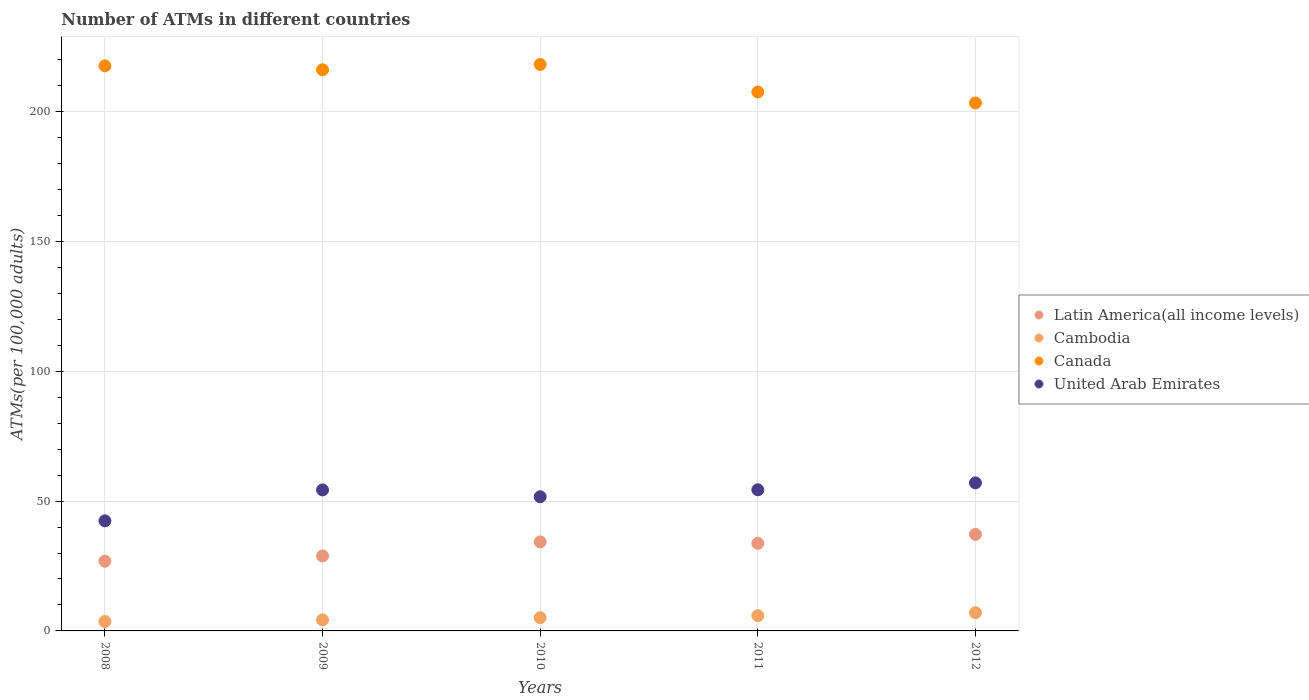How many different coloured dotlines are there?
Give a very brief answer. 4. What is the number of ATMs in United Arab Emirates in 2012?
Offer a very short reply. 57.01. Across all years, what is the maximum number of ATMs in Canada?
Make the answer very short. 218.18. Across all years, what is the minimum number of ATMs in Cambodia?
Your answer should be very brief. 3.63. In which year was the number of ATMs in Cambodia maximum?
Make the answer very short. 2012. In which year was the number of ATMs in Cambodia minimum?
Ensure brevity in your answer.  2008. What is the total number of ATMs in Canada in the graph?
Your answer should be very brief. 1062.81. What is the difference between the number of ATMs in United Arab Emirates in 2008 and that in 2012?
Make the answer very short. -14.62. What is the difference between the number of ATMs in Latin America(all income levels) in 2009 and the number of ATMs in Canada in 2010?
Provide a succinct answer. -189.28. What is the average number of ATMs in Latin America(all income levels) per year?
Make the answer very short. 32.19. In the year 2009, what is the difference between the number of ATMs in United Arab Emirates and number of ATMs in Canada?
Make the answer very short. -161.81. What is the ratio of the number of ATMs in Cambodia in 2010 to that in 2011?
Give a very brief answer. 0.87. What is the difference between the highest and the second highest number of ATMs in United Arab Emirates?
Ensure brevity in your answer.  2.67. What is the difference between the highest and the lowest number of ATMs in Latin America(all income levels)?
Offer a terse response. 10.34. Is the sum of the number of ATMs in Cambodia in 2010 and 2012 greater than the maximum number of ATMs in United Arab Emirates across all years?
Provide a short and direct response. No. Is it the case that in every year, the sum of the number of ATMs in Cambodia and number of ATMs in Latin America(all income levels)  is greater than the number of ATMs in United Arab Emirates?
Offer a terse response. No. How many dotlines are there?
Your answer should be very brief. 4. How many years are there in the graph?
Your answer should be compact. 5. Does the graph contain any zero values?
Your answer should be very brief. No. Where does the legend appear in the graph?
Provide a succinct answer. Center right. What is the title of the graph?
Provide a succinct answer. Number of ATMs in different countries. What is the label or title of the X-axis?
Your answer should be compact. Years. What is the label or title of the Y-axis?
Give a very brief answer. ATMs(per 100,0 adults). What is the ATMs(per 100,000 adults) of Latin America(all income levels) in 2008?
Provide a short and direct response. 26.84. What is the ATMs(per 100,000 adults) in Cambodia in 2008?
Your response must be concise. 3.63. What is the ATMs(per 100,000 adults) of Canada in 2008?
Offer a very short reply. 217.63. What is the ATMs(per 100,000 adults) of United Arab Emirates in 2008?
Offer a very short reply. 42.39. What is the ATMs(per 100,000 adults) of Latin America(all income levels) in 2009?
Give a very brief answer. 28.89. What is the ATMs(per 100,000 adults) in Cambodia in 2009?
Your answer should be compact. 4.25. What is the ATMs(per 100,000 adults) of Canada in 2009?
Make the answer very short. 216.11. What is the ATMs(per 100,000 adults) of United Arab Emirates in 2009?
Your answer should be compact. 54.3. What is the ATMs(per 100,000 adults) in Latin America(all income levels) in 2010?
Your answer should be compact. 34.29. What is the ATMs(per 100,000 adults) in Cambodia in 2010?
Ensure brevity in your answer.  5.12. What is the ATMs(per 100,000 adults) in Canada in 2010?
Ensure brevity in your answer.  218.18. What is the ATMs(per 100,000 adults) in United Arab Emirates in 2010?
Provide a short and direct response. 51.68. What is the ATMs(per 100,000 adults) in Latin America(all income levels) in 2011?
Keep it short and to the point. 33.74. What is the ATMs(per 100,000 adults) in Cambodia in 2011?
Offer a very short reply. 5.87. What is the ATMs(per 100,000 adults) of Canada in 2011?
Provide a succinct answer. 207.56. What is the ATMs(per 100,000 adults) in United Arab Emirates in 2011?
Your answer should be very brief. 54.35. What is the ATMs(per 100,000 adults) of Latin America(all income levels) in 2012?
Give a very brief answer. 37.18. What is the ATMs(per 100,000 adults) in Cambodia in 2012?
Keep it short and to the point. 7. What is the ATMs(per 100,000 adults) in Canada in 2012?
Ensure brevity in your answer.  203.33. What is the ATMs(per 100,000 adults) in United Arab Emirates in 2012?
Offer a terse response. 57.01. Across all years, what is the maximum ATMs(per 100,000 adults) of Latin America(all income levels)?
Provide a short and direct response. 37.18. Across all years, what is the maximum ATMs(per 100,000 adults) of Cambodia?
Your answer should be very brief. 7. Across all years, what is the maximum ATMs(per 100,000 adults) in Canada?
Offer a terse response. 218.18. Across all years, what is the maximum ATMs(per 100,000 adults) of United Arab Emirates?
Offer a very short reply. 57.01. Across all years, what is the minimum ATMs(per 100,000 adults) of Latin America(all income levels)?
Your response must be concise. 26.84. Across all years, what is the minimum ATMs(per 100,000 adults) in Cambodia?
Keep it short and to the point. 3.63. Across all years, what is the minimum ATMs(per 100,000 adults) in Canada?
Your response must be concise. 203.33. Across all years, what is the minimum ATMs(per 100,000 adults) in United Arab Emirates?
Your response must be concise. 42.39. What is the total ATMs(per 100,000 adults) in Latin America(all income levels) in the graph?
Offer a terse response. 160.95. What is the total ATMs(per 100,000 adults) of Cambodia in the graph?
Offer a very short reply. 25.87. What is the total ATMs(per 100,000 adults) in Canada in the graph?
Your answer should be very brief. 1062.81. What is the total ATMs(per 100,000 adults) in United Arab Emirates in the graph?
Your response must be concise. 259.74. What is the difference between the ATMs(per 100,000 adults) in Latin America(all income levels) in 2008 and that in 2009?
Offer a terse response. -2.05. What is the difference between the ATMs(per 100,000 adults) in Cambodia in 2008 and that in 2009?
Keep it short and to the point. -0.62. What is the difference between the ATMs(per 100,000 adults) in Canada in 2008 and that in 2009?
Provide a succinct answer. 1.51. What is the difference between the ATMs(per 100,000 adults) of United Arab Emirates in 2008 and that in 2009?
Offer a very short reply. -11.91. What is the difference between the ATMs(per 100,000 adults) of Latin America(all income levels) in 2008 and that in 2010?
Your answer should be compact. -7.44. What is the difference between the ATMs(per 100,000 adults) in Cambodia in 2008 and that in 2010?
Give a very brief answer. -1.49. What is the difference between the ATMs(per 100,000 adults) of Canada in 2008 and that in 2010?
Provide a short and direct response. -0.55. What is the difference between the ATMs(per 100,000 adults) of United Arab Emirates in 2008 and that in 2010?
Give a very brief answer. -9.29. What is the difference between the ATMs(per 100,000 adults) in Latin America(all income levels) in 2008 and that in 2011?
Make the answer very short. -6.9. What is the difference between the ATMs(per 100,000 adults) of Cambodia in 2008 and that in 2011?
Provide a short and direct response. -2.24. What is the difference between the ATMs(per 100,000 adults) in Canada in 2008 and that in 2011?
Your answer should be very brief. 10.06. What is the difference between the ATMs(per 100,000 adults) in United Arab Emirates in 2008 and that in 2011?
Make the answer very short. -11.95. What is the difference between the ATMs(per 100,000 adults) of Latin America(all income levels) in 2008 and that in 2012?
Provide a short and direct response. -10.34. What is the difference between the ATMs(per 100,000 adults) of Cambodia in 2008 and that in 2012?
Your response must be concise. -3.37. What is the difference between the ATMs(per 100,000 adults) in Canada in 2008 and that in 2012?
Ensure brevity in your answer.  14.3. What is the difference between the ATMs(per 100,000 adults) in United Arab Emirates in 2008 and that in 2012?
Offer a terse response. -14.62. What is the difference between the ATMs(per 100,000 adults) of Latin America(all income levels) in 2009 and that in 2010?
Ensure brevity in your answer.  -5.39. What is the difference between the ATMs(per 100,000 adults) of Cambodia in 2009 and that in 2010?
Provide a short and direct response. -0.87. What is the difference between the ATMs(per 100,000 adults) of Canada in 2009 and that in 2010?
Give a very brief answer. -2.06. What is the difference between the ATMs(per 100,000 adults) of United Arab Emirates in 2009 and that in 2010?
Provide a succinct answer. 2.62. What is the difference between the ATMs(per 100,000 adults) in Latin America(all income levels) in 2009 and that in 2011?
Offer a terse response. -4.85. What is the difference between the ATMs(per 100,000 adults) of Cambodia in 2009 and that in 2011?
Give a very brief answer. -1.62. What is the difference between the ATMs(per 100,000 adults) in Canada in 2009 and that in 2011?
Give a very brief answer. 8.55. What is the difference between the ATMs(per 100,000 adults) in United Arab Emirates in 2009 and that in 2011?
Ensure brevity in your answer.  -0.04. What is the difference between the ATMs(per 100,000 adults) of Latin America(all income levels) in 2009 and that in 2012?
Provide a short and direct response. -8.29. What is the difference between the ATMs(per 100,000 adults) of Cambodia in 2009 and that in 2012?
Ensure brevity in your answer.  -2.76. What is the difference between the ATMs(per 100,000 adults) of Canada in 2009 and that in 2012?
Ensure brevity in your answer.  12.79. What is the difference between the ATMs(per 100,000 adults) in United Arab Emirates in 2009 and that in 2012?
Provide a succinct answer. -2.71. What is the difference between the ATMs(per 100,000 adults) of Latin America(all income levels) in 2010 and that in 2011?
Your response must be concise. 0.54. What is the difference between the ATMs(per 100,000 adults) in Cambodia in 2010 and that in 2011?
Ensure brevity in your answer.  -0.76. What is the difference between the ATMs(per 100,000 adults) of Canada in 2010 and that in 2011?
Offer a very short reply. 10.61. What is the difference between the ATMs(per 100,000 adults) of United Arab Emirates in 2010 and that in 2011?
Give a very brief answer. -2.67. What is the difference between the ATMs(per 100,000 adults) in Latin America(all income levels) in 2010 and that in 2012?
Your response must be concise. -2.9. What is the difference between the ATMs(per 100,000 adults) in Cambodia in 2010 and that in 2012?
Make the answer very short. -1.89. What is the difference between the ATMs(per 100,000 adults) of Canada in 2010 and that in 2012?
Your response must be concise. 14.85. What is the difference between the ATMs(per 100,000 adults) in United Arab Emirates in 2010 and that in 2012?
Offer a terse response. -5.33. What is the difference between the ATMs(per 100,000 adults) of Latin America(all income levels) in 2011 and that in 2012?
Your response must be concise. -3.44. What is the difference between the ATMs(per 100,000 adults) in Cambodia in 2011 and that in 2012?
Your answer should be compact. -1.13. What is the difference between the ATMs(per 100,000 adults) in Canada in 2011 and that in 2012?
Offer a very short reply. 4.24. What is the difference between the ATMs(per 100,000 adults) of United Arab Emirates in 2011 and that in 2012?
Keep it short and to the point. -2.67. What is the difference between the ATMs(per 100,000 adults) of Latin America(all income levels) in 2008 and the ATMs(per 100,000 adults) of Cambodia in 2009?
Give a very brief answer. 22.59. What is the difference between the ATMs(per 100,000 adults) of Latin America(all income levels) in 2008 and the ATMs(per 100,000 adults) of Canada in 2009?
Make the answer very short. -189.27. What is the difference between the ATMs(per 100,000 adults) of Latin America(all income levels) in 2008 and the ATMs(per 100,000 adults) of United Arab Emirates in 2009?
Keep it short and to the point. -27.46. What is the difference between the ATMs(per 100,000 adults) of Cambodia in 2008 and the ATMs(per 100,000 adults) of Canada in 2009?
Keep it short and to the point. -212.48. What is the difference between the ATMs(per 100,000 adults) in Cambodia in 2008 and the ATMs(per 100,000 adults) in United Arab Emirates in 2009?
Keep it short and to the point. -50.67. What is the difference between the ATMs(per 100,000 adults) of Canada in 2008 and the ATMs(per 100,000 adults) of United Arab Emirates in 2009?
Your answer should be very brief. 163.32. What is the difference between the ATMs(per 100,000 adults) in Latin America(all income levels) in 2008 and the ATMs(per 100,000 adults) in Cambodia in 2010?
Your answer should be very brief. 21.73. What is the difference between the ATMs(per 100,000 adults) of Latin America(all income levels) in 2008 and the ATMs(per 100,000 adults) of Canada in 2010?
Provide a succinct answer. -191.33. What is the difference between the ATMs(per 100,000 adults) of Latin America(all income levels) in 2008 and the ATMs(per 100,000 adults) of United Arab Emirates in 2010?
Offer a terse response. -24.84. What is the difference between the ATMs(per 100,000 adults) in Cambodia in 2008 and the ATMs(per 100,000 adults) in Canada in 2010?
Ensure brevity in your answer.  -214.55. What is the difference between the ATMs(per 100,000 adults) of Cambodia in 2008 and the ATMs(per 100,000 adults) of United Arab Emirates in 2010?
Offer a terse response. -48.05. What is the difference between the ATMs(per 100,000 adults) in Canada in 2008 and the ATMs(per 100,000 adults) in United Arab Emirates in 2010?
Keep it short and to the point. 165.95. What is the difference between the ATMs(per 100,000 adults) of Latin America(all income levels) in 2008 and the ATMs(per 100,000 adults) of Cambodia in 2011?
Your response must be concise. 20.97. What is the difference between the ATMs(per 100,000 adults) of Latin America(all income levels) in 2008 and the ATMs(per 100,000 adults) of Canada in 2011?
Make the answer very short. -180.72. What is the difference between the ATMs(per 100,000 adults) of Latin America(all income levels) in 2008 and the ATMs(per 100,000 adults) of United Arab Emirates in 2011?
Offer a terse response. -27.5. What is the difference between the ATMs(per 100,000 adults) of Cambodia in 2008 and the ATMs(per 100,000 adults) of Canada in 2011?
Make the answer very short. -203.93. What is the difference between the ATMs(per 100,000 adults) in Cambodia in 2008 and the ATMs(per 100,000 adults) in United Arab Emirates in 2011?
Offer a very short reply. -50.72. What is the difference between the ATMs(per 100,000 adults) in Canada in 2008 and the ATMs(per 100,000 adults) in United Arab Emirates in 2011?
Your response must be concise. 163.28. What is the difference between the ATMs(per 100,000 adults) of Latin America(all income levels) in 2008 and the ATMs(per 100,000 adults) of Cambodia in 2012?
Give a very brief answer. 19.84. What is the difference between the ATMs(per 100,000 adults) of Latin America(all income levels) in 2008 and the ATMs(per 100,000 adults) of Canada in 2012?
Provide a short and direct response. -176.48. What is the difference between the ATMs(per 100,000 adults) in Latin America(all income levels) in 2008 and the ATMs(per 100,000 adults) in United Arab Emirates in 2012?
Offer a very short reply. -30.17. What is the difference between the ATMs(per 100,000 adults) in Cambodia in 2008 and the ATMs(per 100,000 adults) in Canada in 2012?
Provide a succinct answer. -199.7. What is the difference between the ATMs(per 100,000 adults) in Cambodia in 2008 and the ATMs(per 100,000 adults) in United Arab Emirates in 2012?
Keep it short and to the point. -53.38. What is the difference between the ATMs(per 100,000 adults) of Canada in 2008 and the ATMs(per 100,000 adults) of United Arab Emirates in 2012?
Offer a very short reply. 160.61. What is the difference between the ATMs(per 100,000 adults) in Latin America(all income levels) in 2009 and the ATMs(per 100,000 adults) in Cambodia in 2010?
Provide a succinct answer. 23.78. What is the difference between the ATMs(per 100,000 adults) of Latin America(all income levels) in 2009 and the ATMs(per 100,000 adults) of Canada in 2010?
Offer a very short reply. -189.28. What is the difference between the ATMs(per 100,000 adults) in Latin America(all income levels) in 2009 and the ATMs(per 100,000 adults) in United Arab Emirates in 2010?
Provide a short and direct response. -22.79. What is the difference between the ATMs(per 100,000 adults) in Cambodia in 2009 and the ATMs(per 100,000 adults) in Canada in 2010?
Your response must be concise. -213.93. What is the difference between the ATMs(per 100,000 adults) in Cambodia in 2009 and the ATMs(per 100,000 adults) in United Arab Emirates in 2010?
Ensure brevity in your answer.  -47.43. What is the difference between the ATMs(per 100,000 adults) of Canada in 2009 and the ATMs(per 100,000 adults) of United Arab Emirates in 2010?
Your response must be concise. 164.43. What is the difference between the ATMs(per 100,000 adults) in Latin America(all income levels) in 2009 and the ATMs(per 100,000 adults) in Cambodia in 2011?
Provide a succinct answer. 23.02. What is the difference between the ATMs(per 100,000 adults) of Latin America(all income levels) in 2009 and the ATMs(per 100,000 adults) of Canada in 2011?
Keep it short and to the point. -178.67. What is the difference between the ATMs(per 100,000 adults) of Latin America(all income levels) in 2009 and the ATMs(per 100,000 adults) of United Arab Emirates in 2011?
Keep it short and to the point. -25.46. What is the difference between the ATMs(per 100,000 adults) of Cambodia in 2009 and the ATMs(per 100,000 adults) of Canada in 2011?
Offer a very short reply. -203.31. What is the difference between the ATMs(per 100,000 adults) of Cambodia in 2009 and the ATMs(per 100,000 adults) of United Arab Emirates in 2011?
Keep it short and to the point. -50.1. What is the difference between the ATMs(per 100,000 adults) in Canada in 2009 and the ATMs(per 100,000 adults) in United Arab Emirates in 2011?
Give a very brief answer. 161.77. What is the difference between the ATMs(per 100,000 adults) of Latin America(all income levels) in 2009 and the ATMs(per 100,000 adults) of Cambodia in 2012?
Offer a terse response. 21.89. What is the difference between the ATMs(per 100,000 adults) of Latin America(all income levels) in 2009 and the ATMs(per 100,000 adults) of Canada in 2012?
Give a very brief answer. -174.43. What is the difference between the ATMs(per 100,000 adults) in Latin America(all income levels) in 2009 and the ATMs(per 100,000 adults) in United Arab Emirates in 2012?
Give a very brief answer. -28.12. What is the difference between the ATMs(per 100,000 adults) in Cambodia in 2009 and the ATMs(per 100,000 adults) in Canada in 2012?
Give a very brief answer. -199.08. What is the difference between the ATMs(per 100,000 adults) of Cambodia in 2009 and the ATMs(per 100,000 adults) of United Arab Emirates in 2012?
Give a very brief answer. -52.76. What is the difference between the ATMs(per 100,000 adults) in Canada in 2009 and the ATMs(per 100,000 adults) in United Arab Emirates in 2012?
Offer a very short reply. 159.1. What is the difference between the ATMs(per 100,000 adults) of Latin America(all income levels) in 2010 and the ATMs(per 100,000 adults) of Cambodia in 2011?
Your response must be concise. 28.41. What is the difference between the ATMs(per 100,000 adults) in Latin America(all income levels) in 2010 and the ATMs(per 100,000 adults) in Canada in 2011?
Provide a succinct answer. -173.28. What is the difference between the ATMs(per 100,000 adults) in Latin America(all income levels) in 2010 and the ATMs(per 100,000 adults) in United Arab Emirates in 2011?
Your response must be concise. -20.06. What is the difference between the ATMs(per 100,000 adults) of Cambodia in 2010 and the ATMs(per 100,000 adults) of Canada in 2011?
Make the answer very short. -202.45. What is the difference between the ATMs(per 100,000 adults) of Cambodia in 2010 and the ATMs(per 100,000 adults) of United Arab Emirates in 2011?
Your answer should be very brief. -49.23. What is the difference between the ATMs(per 100,000 adults) in Canada in 2010 and the ATMs(per 100,000 adults) in United Arab Emirates in 2011?
Give a very brief answer. 163.83. What is the difference between the ATMs(per 100,000 adults) in Latin America(all income levels) in 2010 and the ATMs(per 100,000 adults) in Cambodia in 2012?
Make the answer very short. 27.28. What is the difference between the ATMs(per 100,000 adults) in Latin America(all income levels) in 2010 and the ATMs(per 100,000 adults) in Canada in 2012?
Provide a short and direct response. -169.04. What is the difference between the ATMs(per 100,000 adults) of Latin America(all income levels) in 2010 and the ATMs(per 100,000 adults) of United Arab Emirates in 2012?
Provide a succinct answer. -22.73. What is the difference between the ATMs(per 100,000 adults) in Cambodia in 2010 and the ATMs(per 100,000 adults) in Canada in 2012?
Make the answer very short. -198.21. What is the difference between the ATMs(per 100,000 adults) of Cambodia in 2010 and the ATMs(per 100,000 adults) of United Arab Emirates in 2012?
Provide a succinct answer. -51.9. What is the difference between the ATMs(per 100,000 adults) of Canada in 2010 and the ATMs(per 100,000 adults) of United Arab Emirates in 2012?
Provide a succinct answer. 161.16. What is the difference between the ATMs(per 100,000 adults) in Latin America(all income levels) in 2011 and the ATMs(per 100,000 adults) in Cambodia in 2012?
Provide a succinct answer. 26.74. What is the difference between the ATMs(per 100,000 adults) in Latin America(all income levels) in 2011 and the ATMs(per 100,000 adults) in Canada in 2012?
Provide a succinct answer. -169.58. What is the difference between the ATMs(per 100,000 adults) of Latin America(all income levels) in 2011 and the ATMs(per 100,000 adults) of United Arab Emirates in 2012?
Offer a terse response. -23.27. What is the difference between the ATMs(per 100,000 adults) of Cambodia in 2011 and the ATMs(per 100,000 adults) of Canada in 2012?
Offer a terse response. -197.45. What is the difference between the ATMs(per 100,000 adults) of Cambodia in 2011 and the ATMs(per 100,000 adults) of United Arab Emirates in 2012?
Make the answer very short. -51.14. What is the difference between the ATMs(per 100,000 adults) in Canada in 2011 and the ATMs(per 100,000 adults) in United Arab Emirates in 2012?
Keep it short and to the point. 150.55. What is the average ATMs(per 100,000 adults) in Latin America(all income levels) per year?
Your response must be concise. 32.19. What is the average ATMs(per 100,000 adults) in Cambodia per year?
Your answer should be compact. 5.17. What is the average ATMs(per 100,000 adults) of Canada per year?
Provide a succinct answer. 212.56. What is the average ATMs(per 100,000 adults) of United Arab Emirates per year?
Provide a succinct answer. 51.95. In the year 2008, what is the difference between the ATMs(per 100,000 adults) of Latin America(all income levels) and ATMs(per 100,000 adults) of Cambodia?
Give a very brief answer. 23.21. In the year 2008, what is the difference between the ATMs(per 100,000 adults) of Latin America(all income levels) and ATMs(per 100,000 adults) of Canada?
Keep it short and to the point. -190.78. In the year 2008, what is the difference between the ATMs(per 100,000 adults) of Latin America(all income levels) and ATMs(per 100,000 adults) of United Arab Emirates?
Offer a terse response. -15.55. In the year 2008, what is the difference between the ATMs(per 100,000 adults) in Cambodia and ATMs(per 100,000 adults) in Canada?
Offer a terse response. -214. In the year 2008, what is the difference between the ATMs(per 100,000 adults) in Cambodia and ATMs(per 100,000 adults) in United Arab Emirates?
Make the answer very short. -38.76. In the year 2008, what is the difference between the ATMs(per 100,000 adults) in Canada and ATMs(per 100,000 adults) in United Arab Emirates?
Provide a short and direct response. 175.23. In the year 2009, what is the difference between the ATMs(per 100,000 adults) in Latin America(all income levels) and ATMs(per 100,000 adults) in Cambodia?
Your answer should be very brief. 24.64. In the year 2009, what is the difference between the ATMs(per 100,000 adults) in Latin America(all income levels) and ATMs(per 100,000 adults) in Canada?
Provide a succinct answer. -187.22. In the year 2009, what is the difference between the ATMs(per 100,000 adults) of Latin America(all income levels) and ATMs(per 100,000 adults) of United Arab Emirates?
Make the answer very short. -25.41. In the year 2009, what is the difference between the ATMs(per 100,000 adults) in Cambodia and ATMs(per 100,000 adults) in Canada?
Keep it short and to the point. -211.87. In the year 2009, what is the difference between the ATMs(per 100,000 adults) in Cambodia and ATMs(per 100,000 adults) in United Arab Emirates?
Make the answer very short. -50.06. In the year 2009, what is the difference between the ATMs(per 100,000 adults) in Canada and ATMs(per 100,000 adults) in United Arab Emirates?
Your answer should be very brief. 161.81. In the year 2010, what is the difference between the ATMs(per 100,000 adults) of Latin America(all income levels) and ATMs(per 100,000 adults) of Cambodia?
Give a very brief answer. 29.17. In the year 2010, what is the difference between the ATMs(per 100,000 adults) in Latin America(all income levels) and ATMs(per 100,000 adults) in Canada?
Ensure brevity in your answer.  -183.89. In the year 2010, what is the difference between the ATMs(per 100,000 adults) in Latin America(all income levels) and ATMs(per 100,000 adults) in United Arab Emirates?
Make the answer very short. -17.39. In the year 2010, what is the difference between the ATMs(per 100,000 adults) in Cambodia and ATMs(per 100,000 adults) in Canada?
Your answer should be compact. -213.06. In the year 2010, what is the difference between the ATMs(per 100,000 adults) in Cambodia and ATMs(per 100,000 adults) in United Arab Emirates?
Your answer should be very brief. -46.56. In the year 2010, what is the difference between the ATMs(per 100,000 adults) of Canada and ATMs(per 100,000 adults) of United Arab Emirates?
Provide a short and direct response. 166.5. In the year 2011, what is the difference between the ATMs(per 100,000 adults) in Latin America(all income levels) and ATMs(per 100,000 adults) in Cambodia?
Provide a short and direct response. 27.87. In the year 2011, what is the difference between the ATMs(per 100,000 adults) in Latin America(all income levels) and ATMs(per 100,000 adults) in Canada?
Your answer should be compact. -173.82. In the year 2011, what is the difference between the ATMs(per 100,000 adults) in Latin America(all income levels) and ATMs(per 100,000 adults) in United Arab Emirates?
Offer a very short reply. -20.6. In the year 2011, what is the difference between the ATMs(per 100,000 adults) in Cambodia and ATMs(per 100,000 adults) in Canada?
Keep it short and to the point. -201.69. In the year 2011, what is the difference between the ATMs(per 100,000 adults) of Cambodia and ATMs(per 100,000 adults) of United Arab Emirates?
Offer a very short reply. -48.47. In the year 2011, what is the difference between the ATMs(per 100,000 adults) of Canada and ATMs(per 100,000 adults) of United Arab Emirates?
Your answer should be compact. 153.22. In the year 2012, what is the difference between the ATMs(per 100,000 adults) in Latin America(all income levels) and ATMs(per 100,000 adults) in Cambodia?
Make the answer very short. 30.18. In the year 2012, what is the difference between the ATMs(per 100,000 adults) in Latin America(all income levels) and ATMs(per 100,000 adults) in Canada?
Offer a very short reply. -166.14. In the year 2012, what is the difference between the ATMs(per 100,000 adults) in Latin America(all income levels) and ATMs(per 100,000 adults) in United Arab Emirates?
Provide a succinct answer. -19.83. In the year 2012, what is the difference between the ATMs(per 100,000 adults) of Cambodia and ATMs(per 100,000 adults) of Canada?
Offer a terse response. -196.32. In the year 2012, what is the difference between the ATMs(per 100,000 adults) in Cambodia and ATMs(per 100,000 adults) in United Arab Emirates?
Give a very brief answer. -50.01. In the year 2012, what is the difference between the ATMs(per 100,000 adults) of Canada and ATMs(per 100,000 adults) of United Arab Emirates?
Your response must be concise. 146.31. What is the ratio of the ATMs(per 100,000 adults) in Latin America(all income levels) in 2008 to that in 2009?
Offer a very short reply. 0.93. What is the ratio of the ATMs(per 100,000 adults) of Cambodia in 2008 to that in 2009?
Keep it short and to the point. 0.85. What is the ratio of the ATMs(per 100,000 adults) of Canada in 2008 to that in 2009?
Ensure brevity in your answer.  1.01. What is the ratio of the ATMs(per 100,000 adults) of United Arab Emirates in 2008 to that in 2009?
Your answer should be very brief. 0.78. What is the ratio of the ATMs(per 100,000 adults) of Latin America(all income levels) in 2008 to that in 2010?
Offer a terse response. 0.78. What is the ratio of the ATMs(per 100,000 adults) of Cambodia in 2008 to that in 2010?
Your answer should be compact. 0.71. What is the ratio of the ATMs(per 100,000 adults) of Canada in 2008 to that in 2010?
Make the answer very short. 1. What is the ratio of the ATMs(per 100,000 adults) of United Arab Emirates in 2008 to that in 2010?
Keep it short and to the point. 0.82. What is the ratio of the ATMs(per 100,000 adults) of Latin America(all income levels) in 2008 to that in 2011?
Ensure brevity in your answer.  0.8. What is the ratio of the ATMs(per 100,000 adults) in Cambodia in 2008 to that in 2011?
Provide a short and direct response. 0.62. What is the ratio of the ATMs(per 100,000 adults) in Canada in 2008 to that in 2011?
Provide a short and direct response. 1.05. What is the ratio of the ATMs(per 100,000 adults) of United Arab Emirates in 2008 to that in 2011?
Make the answer very short. 0.78. What is the ratio of the ATMs(per 100,000 adults) of Latin America(all income levels) in 2008 to that in 2012?
Provide a short and direct response. 0.72. What is the ratio of the ATMs(per 100,000 adults) of Cambodia in 2008 to that in 2012?
Offer a terse response. 0.52. What is the ratio of the ATMs(per 100,000 adults) in Canada in 2008 to that in 2012?
Offer a terse response. 1.07. What is the ratio of the ATMs(per 100,000 adults) in United Arab Emirates in 2008 to that in 2012?
Keep it short and to the point. 0.74. What is the ratio of the ATMs(per 100,000 adults) of Latin America(all income levels) in 2009 to that in 2010?
Your answer should be very brief. 0.84. What is the ratio of the ATMs(per 100,000 adults) of Cambodia in 2009 to that in 2010?
Keep it short and to the point. 0.83. What is the ratio of the ATMs(per 100,000 adults) of United Arab Emirates in 2009 to that in 2010?
Provide a succinct answer. 1.05. What is the ratio of the ATMs(per 100,000 adults) in Latin America(all income levels) in 2009 to that in 2011?
Your answer should be very brief. 0.86. What is the ratio of the ATMs(per 100,000 adults) in Cambodia in 2009 to that in 2011?
Your answer should be very brief. 0.72. What is the ratio of the ATMs(per 100,000 adults) of Canada in 2009 to that in 2011?
Your answer should be compact. 1.04. What is the ratio of the ATMs(per 100,000 adults) in Latin America(all income levels) in 2009 to that in 2012?
Your answer should be very brief. 0.78. What is the ratio of the ATMs(per 100,000 adults) in Cambodia in 2009 to that in 2012?
Your answer should be very brief. 0.61. What is the ratio of the ATMs(per 100,000 adults) of Canada in 2009 to that in 2012?
Your answer should be very brief. 1.06. What is the ratio of the ATMs(per 100,000 adults) of United Arab Emirates in 2009 to that in 2012?
Your response must be concise. 0.95. What is the ratio of the ATMs(per 100,000 adults) in Latin America(all income levels) in 2010 to that in 2011?
Ensure brevity in your answer.  1.02. What is the ratio of the ATMs(per 100,000 adults) of Cambodia in 2010 to that in 2011?
Give a very brief answer. 0.87. What is the ratio of the ATMs(per 100,000 adults) in Canada in 2010 to that in 2011?
Make the answer very short. 1.05. What is the ratio of the ATMs(per 100,000 adults) in United Arab Emirates in 2010 to that in 2011?
Give a very brief answer. 0.95. What is the ratio of the ATMs(per 100,000 adults) in Latin America(all income levels) in 2010 to that in 2012?
Your answer should be very brief. 0.92. What is the ratio of the ATMs(per 100,000 adults) in Cambodia in 2010 to that in 2012?
Your response must be concise. 0.73. What is the ratio of the ATMs(per 100,000 adults) in Canada in 2010 to that in 2012?
Give a very brief answer. 1.07. What is the ratio of the ATMs(per 100,000 adults) in United Arab Emirates in 2010 to that in 2012?
Your answer should be compact. 0.91. What is the ratio of the ATMs(per 100,000 adults) of Latin America(all income levels) in 2011 to that in 2012?
Give a very brief answer. 0.91. What is the ratio of the ATMs(per 100,000 adults) in Cambodia in 2011 to that in 2012?
Provide a short and direct response. 0.84. What is the ratio of the ATMs(per 100,000 adults) of Canada in 2011 to that in 2012?
Your answer should be very brief. 1.02. What is the ratio of the ATMs(per 100,000 adults) of United Arab Emirates in 2011 to that in 2012?
Offer a terse response. 0.95. What is the difference between the highest and the second highest ATMs(per 100,000 adults) of Latin America(all income levels)?
Make the answer very short. 2.9. What is the difference between the highest and the second highest ATMs(per 100,000 adults) in Cambodia?
Your answer should be compact. 1.13. What is the difference between the highest and the second highest ATMs(per 100,000 adults) of Canada?
Your answer should be very brief. 0.55. What is the difference between the highest and the second highest ATMs(per 100,000 adults) in United Arab Emirates?
Provide a short and direct response. 2.67. What is the difference between the highest and the lowest ATMs(per 100,000 adults) in Latin America(all income levels)?
Provide a short and direct response. 10.34. What is the difference between the highest and the lowest ATMs(per 100,000 adults) in Cambodia?
Your response must be concise. 3.37. What is the difference between the highest and the lowest ATMs(per 100,000 adults) of Canada?
Your answer should be very brief. 14.85. What is the difference between the highest and the lowest ATMs(per 100,000 adults) in United Arab Emirates?
Give a very brief answer. 14.62. 